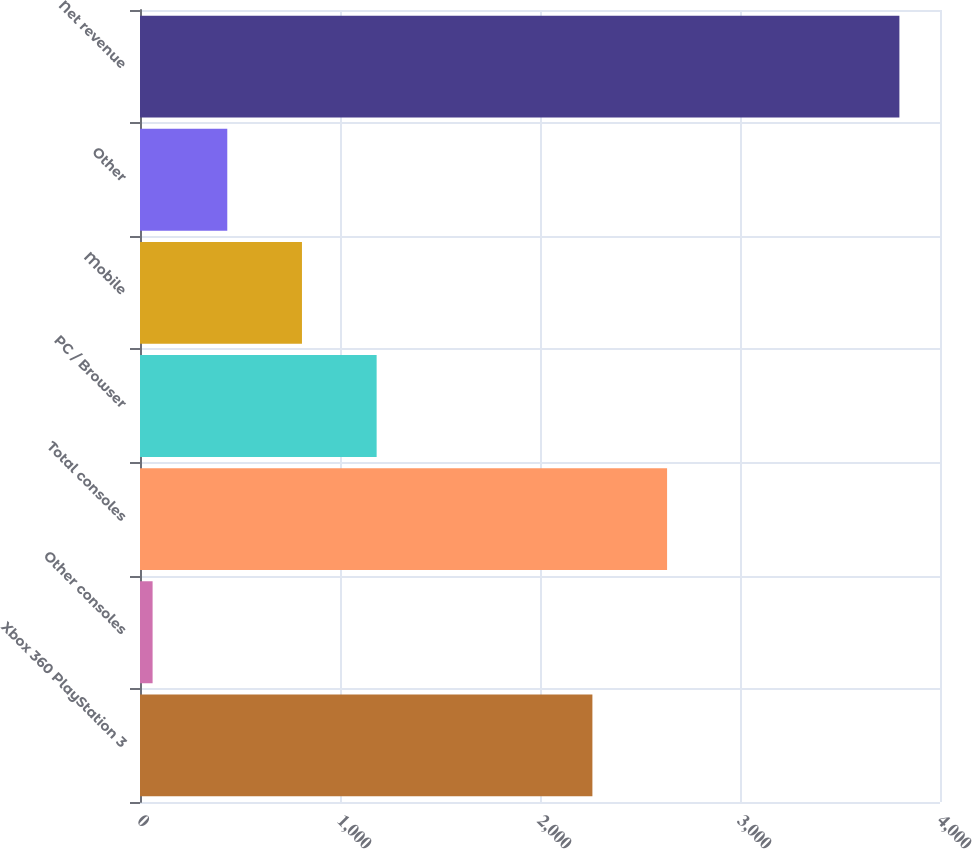Convert chart to OTSL. <chart><loc_0><loc_0><loc_500><loc_500><bar_chart><fcel>Xbox 360 PlayStation 3<fcel>Other consoles<fcel>Total consoles<fcel>PC / Browser<fcel>Mobile<fcel>Other<fcel>Net revenue<nl><fcel>2262<fcel>63<fcel>2635.4<fcel>1183.2<fcel>809.8<fcel>436.4<fcel>3797<nl></chart> 